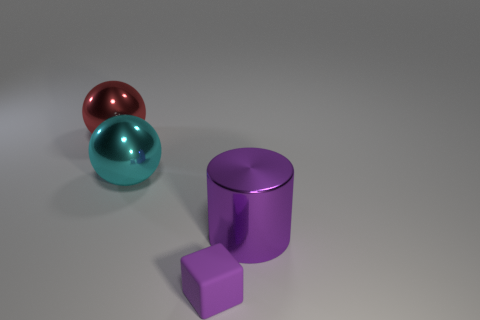There is a big shiny thing that is to the right of the purple thing in front of the big object that is to the right of the cyan shiny object; what is its shape?
Provide a short and direct response. Cylinder. How many green objects are big shiny spheres or big cylinders?
Ensure brevity in your answer.  0. How many blocks are behind the big object that is in front of the cyan object?
Your answer should be compact. 0. Is there any other thing of the same color as the rubber block?
Offer a very short reply. Yes. The purple object that is the same material as the cyan thing is what shape?
Provide a short and direct response. Cylinder. Do the rubber object and the large metal cylinder have the same color?
Your response must be concise. Yes. Is the material of the big thing that is behind the big cyan metallic ball the same as the big object that is in front of the cyan ball?
Ensure brevity in your answer.  Yes. How many objects are either large cyan metal balls or big things that are in front of the red metallic thing?
Your answer should be compact. 2. Are there any other things that have the same material as the cyan object?
Provide a succinct answer. Yes. There is a small thing that is the same color as the cylinder; what is its shape?
Keep it short and to the point. Cube. 